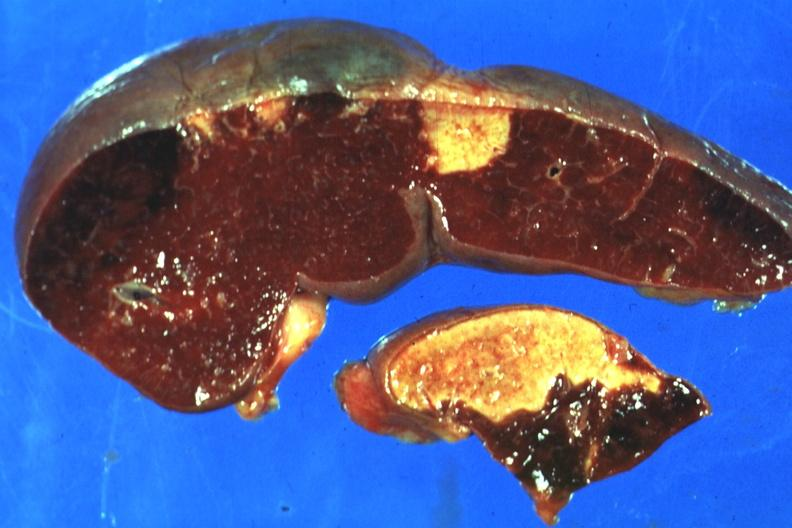how is excellent side with four infarcts shown which are several days of age from endocarditis?
Answer the question using a single word or phrase. Nonbacterial 